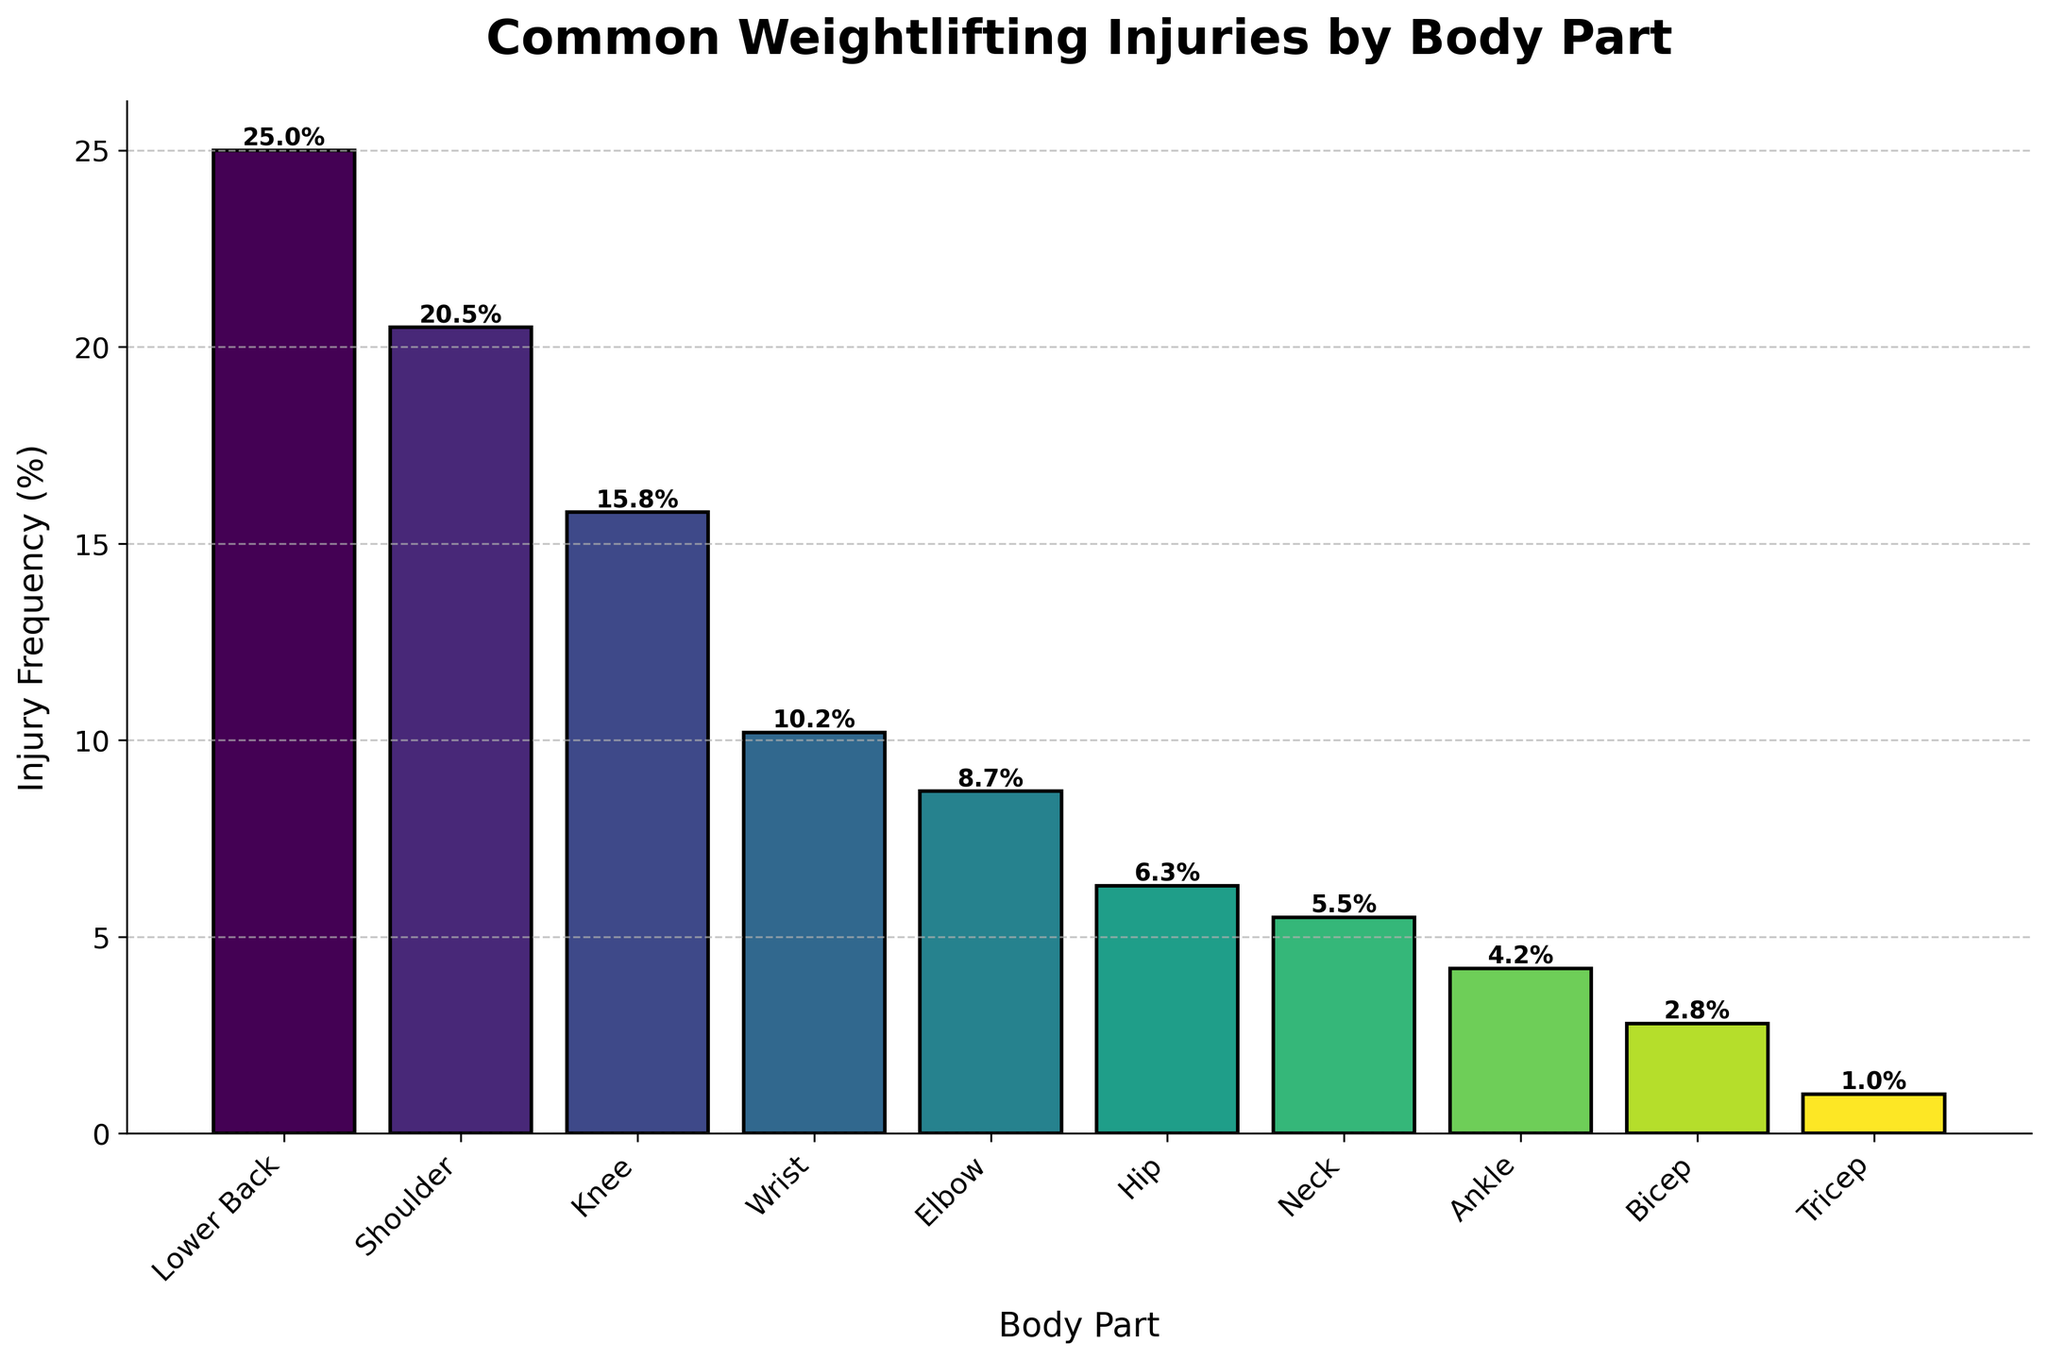Which body part has the highest injury frequency? The bar representing the injury frequency for the Lower Back is the tallest, indicating that it has the highest frequency.
Answer: Lower Back Which body part has the lowest injury frequency? The bar representing the injury frequency for the Tricep is the shortest, indicating that it has the lowest frequency.
Answer: Tricep How does the injury frequency for the Shoulder compare to that of the Knee? The bar for the Shoulder is slightly taller than the bar for the Knee, indicating that the injury frequency for the Shoulder is higher.
Answer: Shoulder What's the difference in injury frequency between the Lower Back and the Ankle? The injury frequency for the Lower Back is 25.0% and for the Ankle is 4.2%. The difference is 25.0% - 4.2% = 20.8%.
Answer: 20.8% Which body part has an injury frequency closest to 10%? The bar for the Wrist shows an injury frequency of 10.2%, which is closest to 10%.
Answer: Wrist What's the combined injury frequency for the Knee and the Hip? The injury frequency for the Knee is 15.8% and for the Hip is 6.3%. The combined frequency is 15.8% + 6.3% = 22.1%.
Answer: 22.1% Are there more injuries in the Upper Body (Shoulder, Wrist, Elbow, Neck, Bicep, Tricep) or Lower Body (Lower Back, Knee, Hip, Ankle)? Sum the frequencies for Upper Body: 20.5% (Shoulder) + 10.2% (Wrist) + 8.7% (Elbow) + 5.5% (Neck) + 2.8% (Bicep) + 1.0% (Tricep) = 48.7%. Sum the frequencies for Lower Body: 25.0% (Lower Back) + 15.8% (Knee) + 6.3% (Hip) + 4.2% (Ankle) = 51.3%. More injuries are in the Lower Body.
Answer: Lower Body What is the average injury frequency for Shoulder, Elbow, and Neck? Sum the frequencies for Shoulder (20.5%), Elbow (8.7%), and Neck (5.5%). (20.5% + 8.7% + 5.5%) / 3 = 11.57%
Answer: 11.57% What's the total injury frequency for Lower Back, Shoulder, and Knee? Sum the frequencies of Lower Back (25.0%), Shoulder (20.5%), and Knee (15.8%). 25.0% + 20.5% + 15.8% = 61.3%.
Answer: 61.3% 